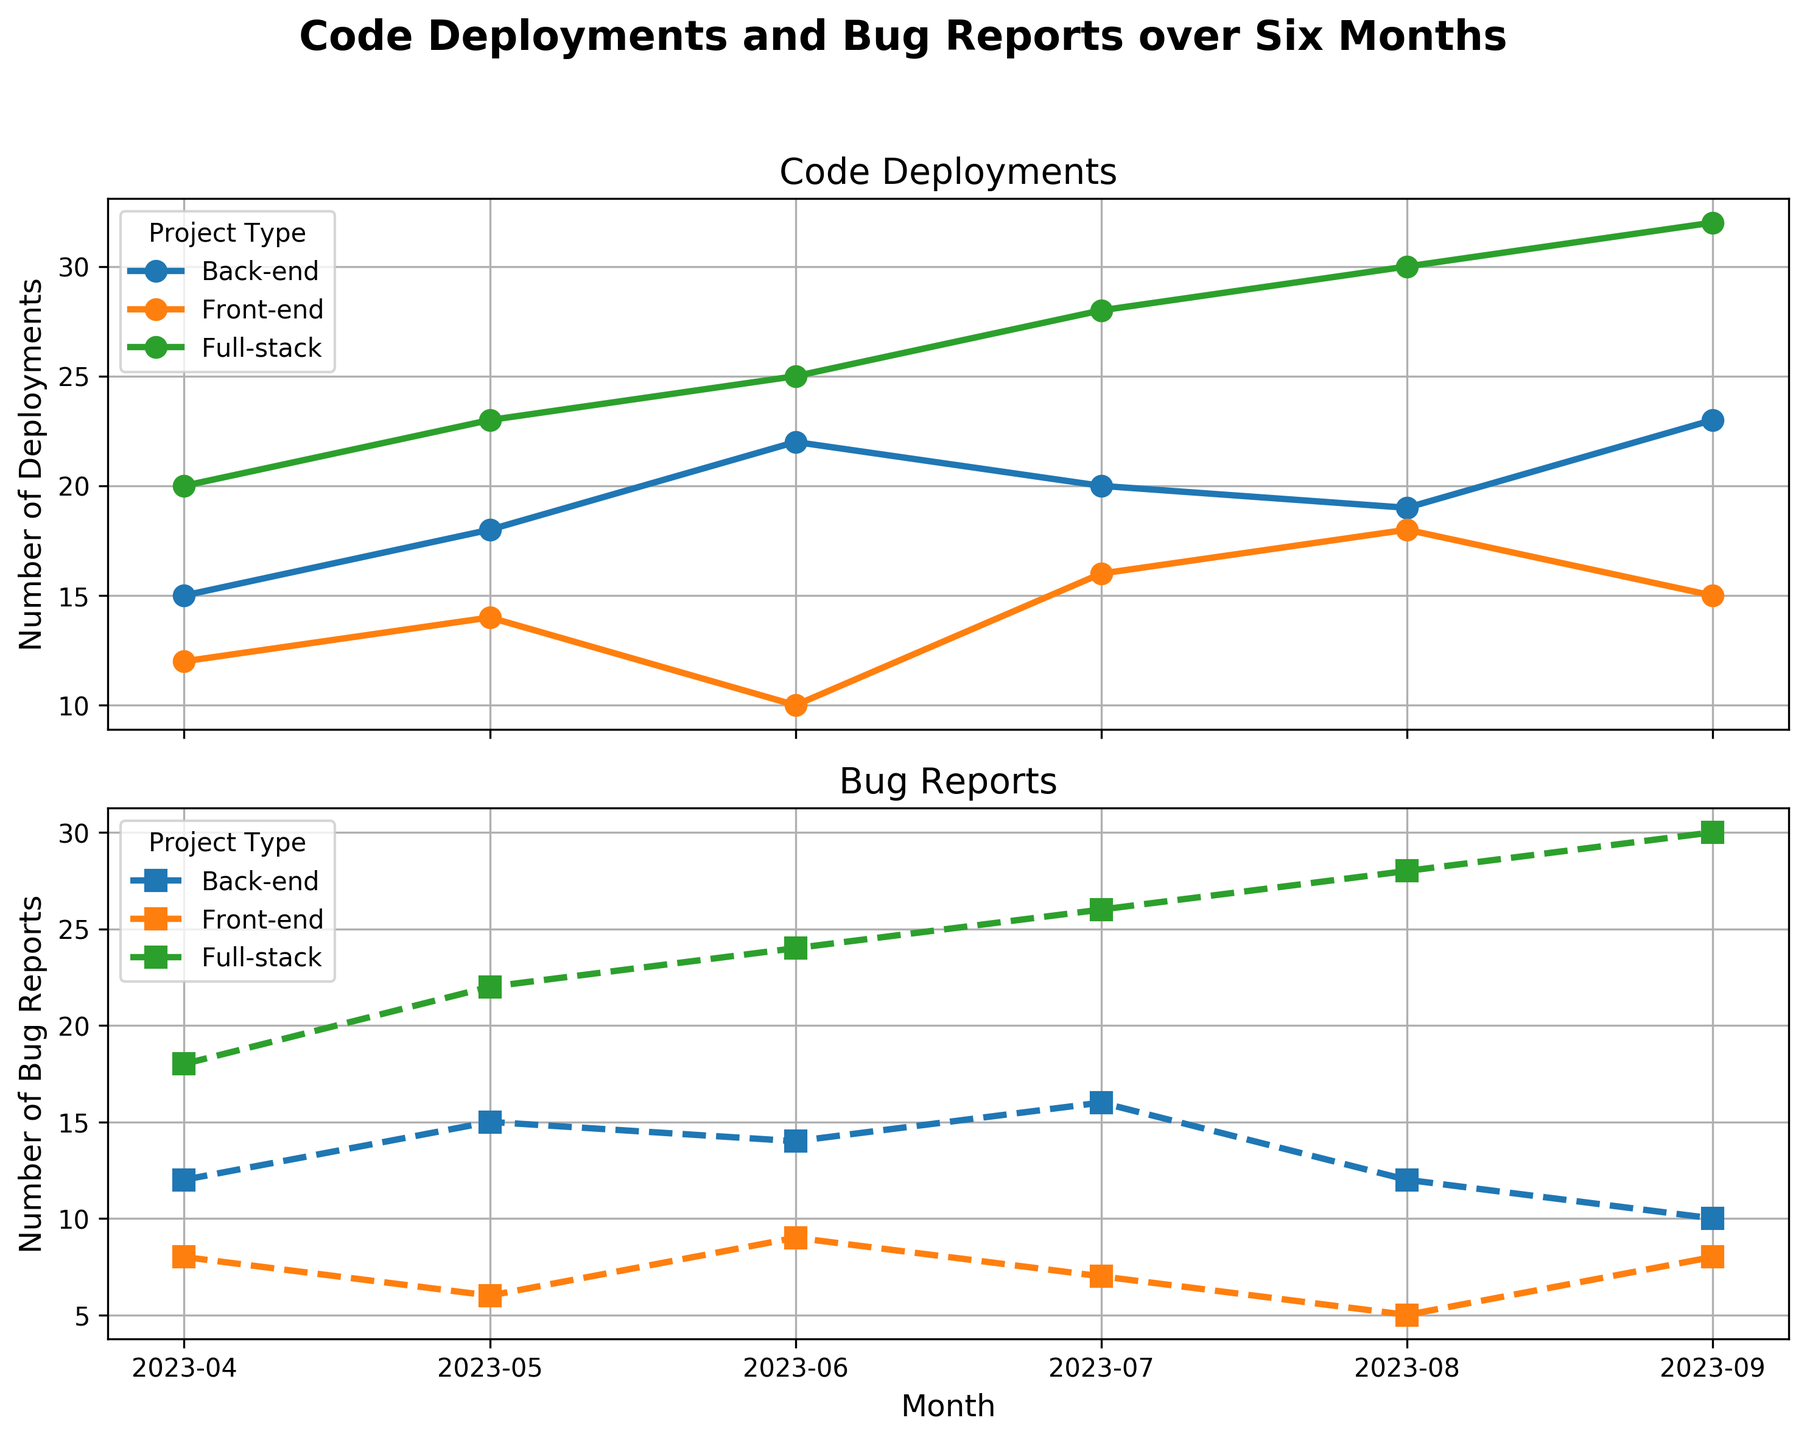Which project type had the highest number of bug reports in May 2023? From the plot, observe the data points for May 2023. For bug reports, the Full-stack project has the highest with 22.
Answer: Full-stack Between which two months did the front-end code deployments see the greatest increase? Check the increment in the front-end code deployments line chart. The greatest increase is from June (10) to July (16), an increase of 6 deployments.
Answer: From June to July By how many did the number of code deployments for back-end projects increase from April 2023 to September 2023? Look at the back-end deployment values for April (15) and September (23). The increase is 23 - 15 = 8.
Answer: 8 Compare the number of bug reports between back-end and front-end projects in August 2023. Which had more, and by how many? Observe the August data points. Back-end had 12 bug reports, and front-end had 5 bug reports. The back-end had 12 - 5 = 7 more bug reports.
Answer: Back-end by 7 What is the total count of code deployments for full-stack projects over the six months? Add the full-stack code deployments: 20+23+25+28+30+32 = 158 deployments.
Answer: 158 Which project type shows the most significant reduction in bug reports from June to July 2023? From June to July: Front-end goes from 9 to 7, back-end from 14 to 16 (increase), and full-stack from 24 to 26 (increase). Front-end drops by 2.
Answer: Front-end What is the average number of code deployments for front-end projects over the six-month period? Sum up front-end code deployments (12+14+10+16+18+15) = 85, divide by 6 months, the average is 85/6 = 14.17.
Answer: 14.17 Which project type consistently had the fewest bug reports in all six months? From the bug report plot, the Front-end project type consistently had the fewest bug reports each month.
Answer: Front-end How does the trend of bug reports in full-stack projects compare visually to that in back-end projects? Visually, the full-stack bug reports trend upwards consistently, while the back-end project bug reports fluctuate, but generally stay lower than full-stack reports.
Answer: Full-stack trends upward, back-end fluctuates Between July and August 2023, which project type shows a decrease in code deployments, and by how many? Observe each project's change from July to August. None of the projects (front-end, back-end, full-stack) show a decrease. They all increased.
Answer: None 